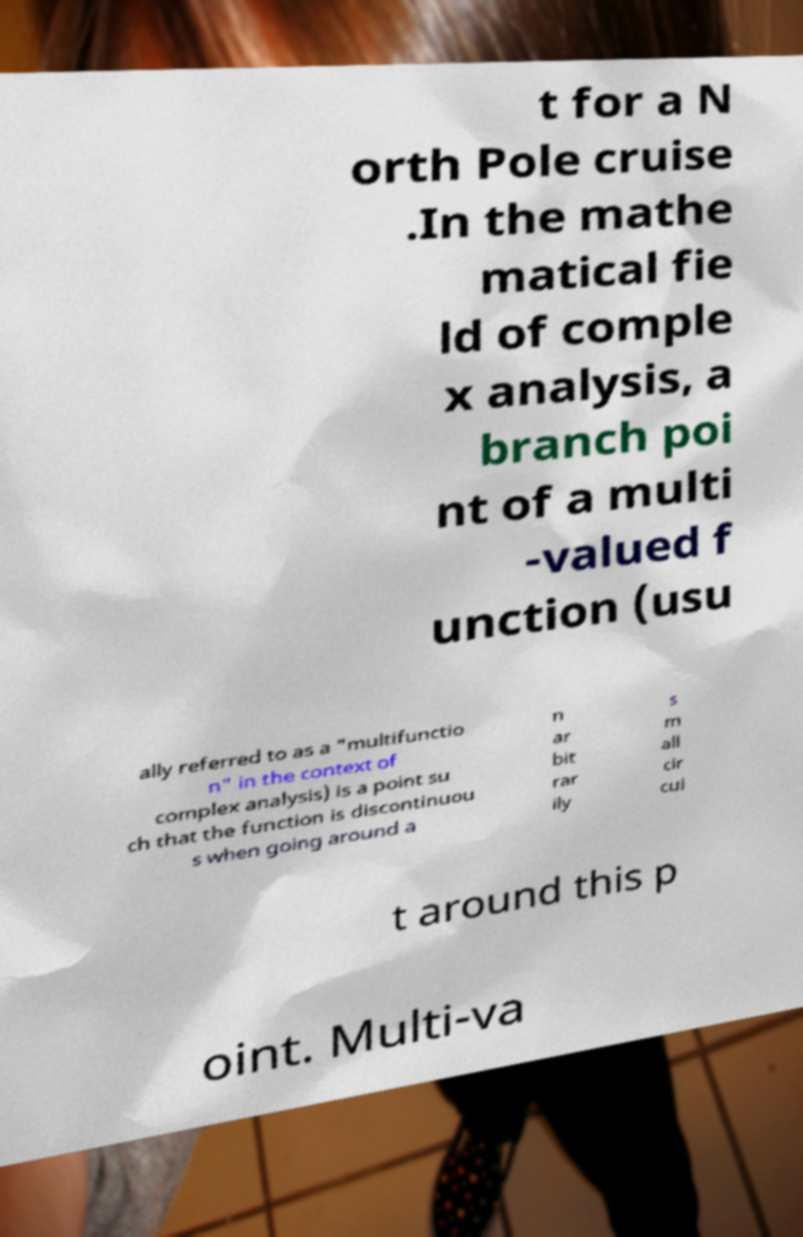Can you read and provide the text displayed in the image?This photo seems to have some interesting text. Can you extract and type it out for me? t for a N orth Pole cruise .In the mathe matical fie ld of comple x analysis, a branch poi nt of a multi -valued f unction (usu ally referred to as a "multifunctio n" in the context of complex analysis) is a point su ch that the function is discontinuou s when going around a n ar bit rar ily s m all cir cui t around this p oint. Multi-va 